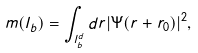<formula> <loc_0><loc_0><loc_500><loc_500>m ( l _ { b } ) = \int _ { l _ { b } ^ { d } } d { r } | \Psi ( { r } + { r } _ { 0 } ) | ^ { 2 } ,</formula> 